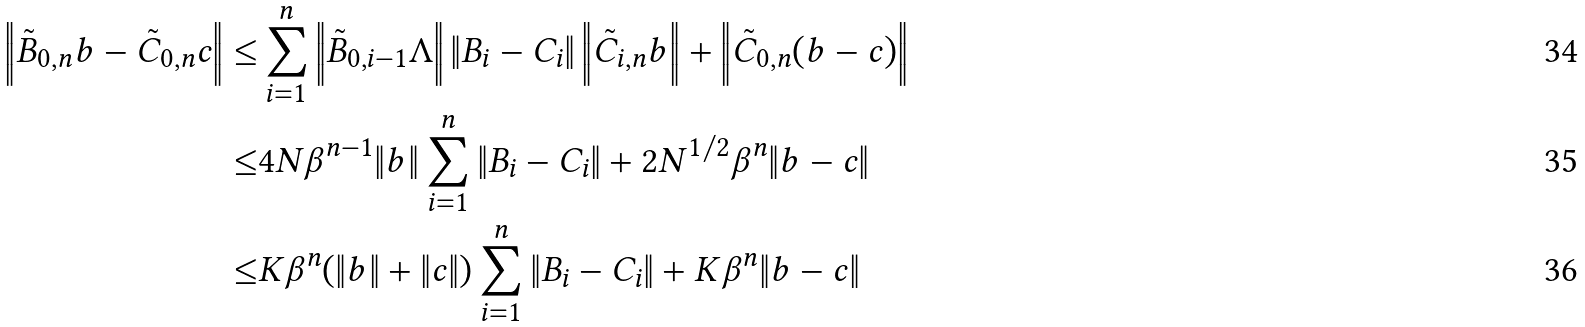Convert formula to latex. <formula><loc_0><loc_0><loc_500><loc_500>\left \| \tilde { B } _ { 0 , n } b - \tilde { C } _ { 0 , n } c \right \| \leq & \sum _ { i = 1 } ^ { n } \left \| \tilde { B } _ { 0 , i - 1 } \Lambda \right \| \| B _ { i } - C _ { i } \| \left \| \tilde { C } _ { i , n } b \right \| + \left \| \tilde { C } _ { 0 , n } ( b - c ) \right \| \\ \leq & 4 N \beta ^ { n - 1 } \| b \| \sum _ { i = 1 } ^ { n } \| B _ { i } - C _ { i } \| + 2 N ^ { 1 / 2 } \beta ^ { n } \| b - c \| \\ \leq & K \beta ^ { n } ( \| b \| + \| c \| ) \sum _ { i = 1 } ^ { n } \| B _ { i } - C _ { i } \| + K \beta ^ { n } \| b - c \|</formula> 